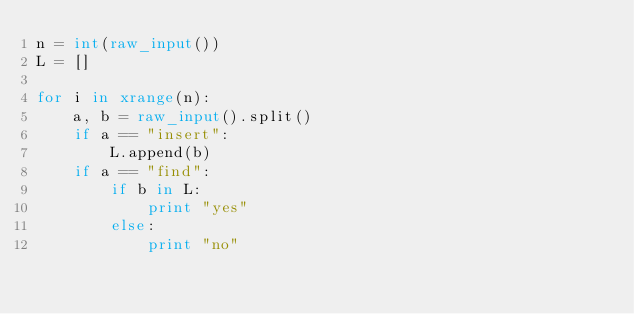Convert code to text. <code><loc_0><loc_0><loc_500><loc_500><_Python_>n = int(raw_input())
L = []

for i in xrange(n):
    a, b = raw_input().split()
    if a == "insert":
        L.append(b)
    if a == "find":
        if b in L:
            print "yes"
        else:
            print "no"</code> 